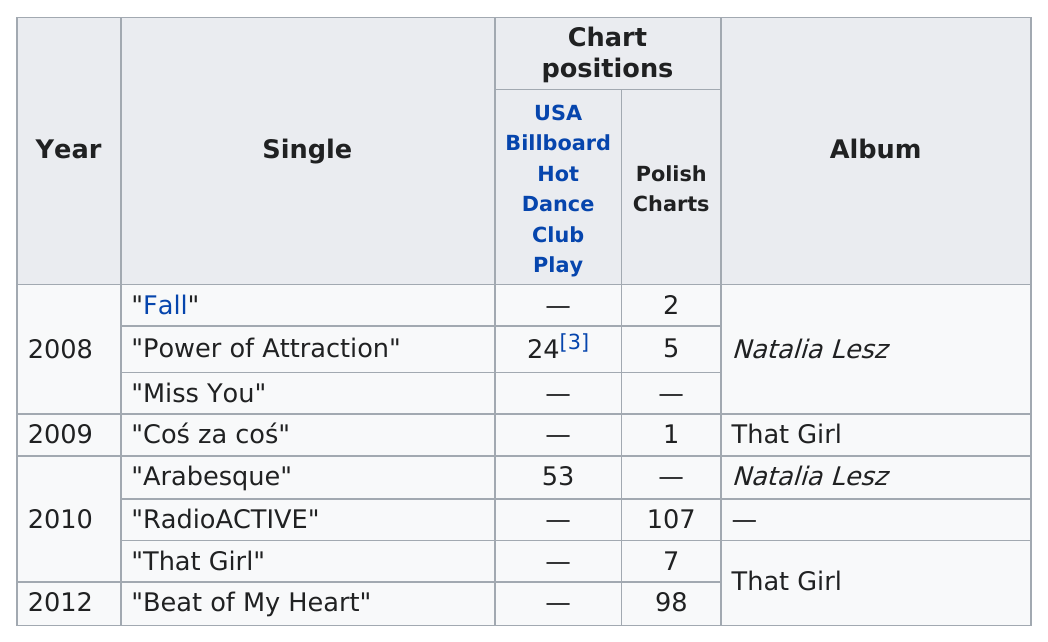Mention a couple of crucial points in this snapshot. The single named "RadioACTIVE" does not belong to any album. In 2010, a total of 3 singles were released. That girl" came before "miss you" since "miss you" is a contraction of "you are missed. Beat of My Heart," the single released after 2011, is a declaration of love and passion for someone special. The number of singles that made the billboards is two. 